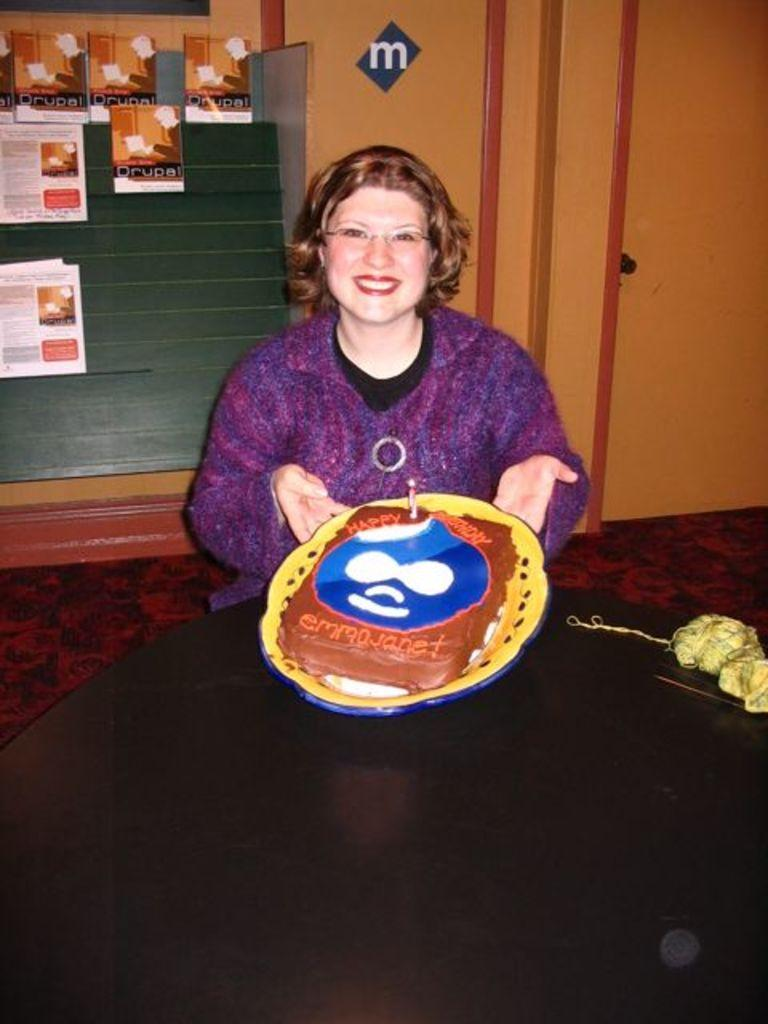Who is present in the image? There is a woman in the image. What is the woman doing in the image? The woman is sitting in a chair and smiling. What is the woman holding in the image? The woman is holding a cake. Where is the cake located in the image? The cake is on a table. What can be seen on the wall in the background of the image? There are frames attached to the wall in the background. What architectural feature is visible in the background of the image? There is a door in the background. What type of flooring is present in the background of the image? There is a carpet in the background. What other object is present on a table in the background of the image? There is a rope on a table in the background. How many planes are flying over the cemetery in the image? There is no cemetery or planes present in the image. 